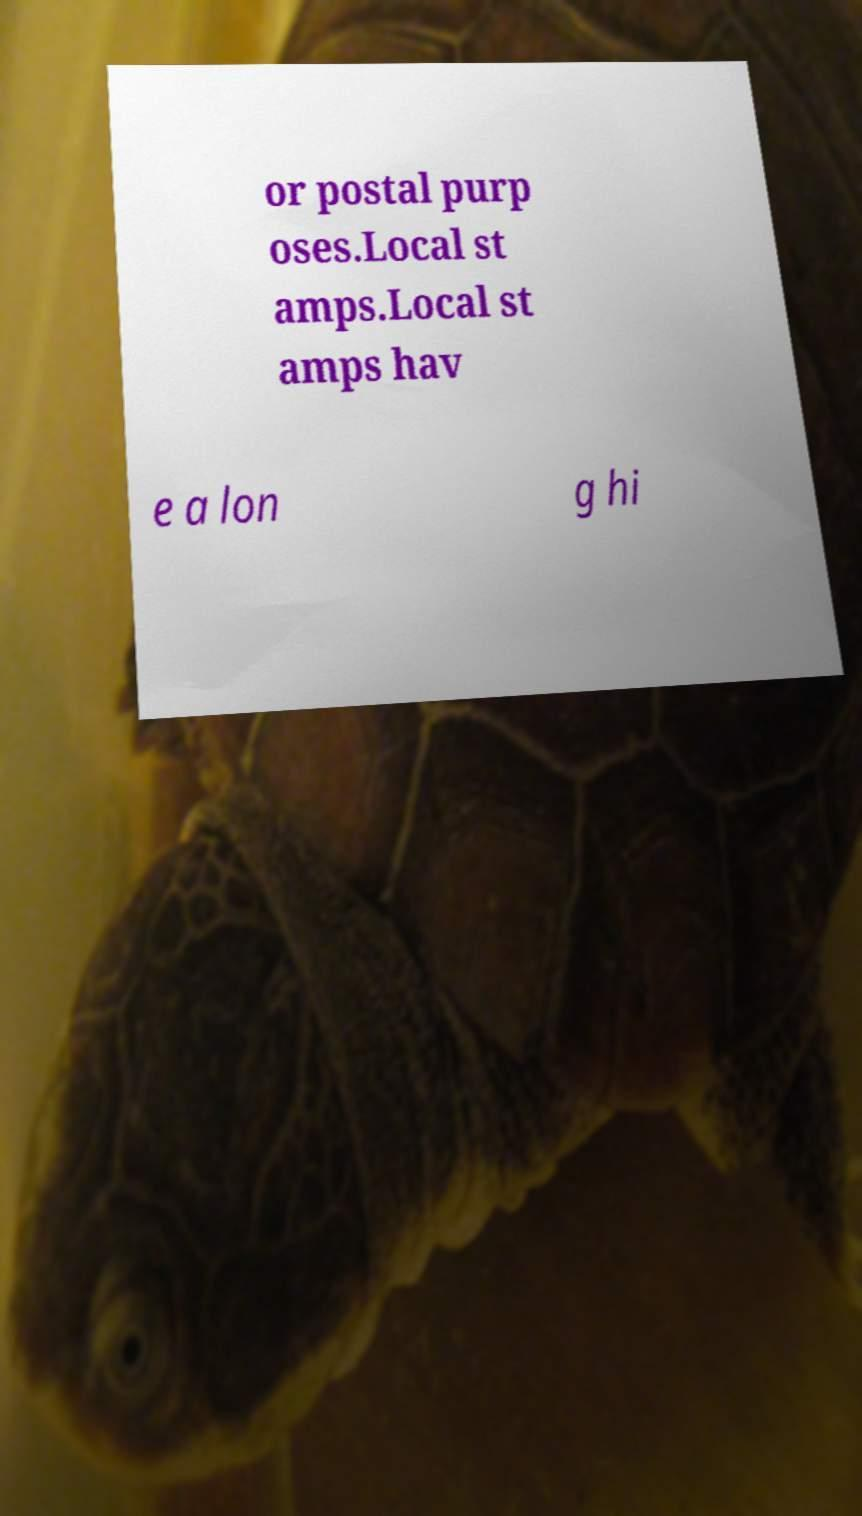There's text embedded in this image that I need extracted. Can you transcribe it verbatim? or postal purp oses.Local st amps.Local st amps hav e a lon g hi 